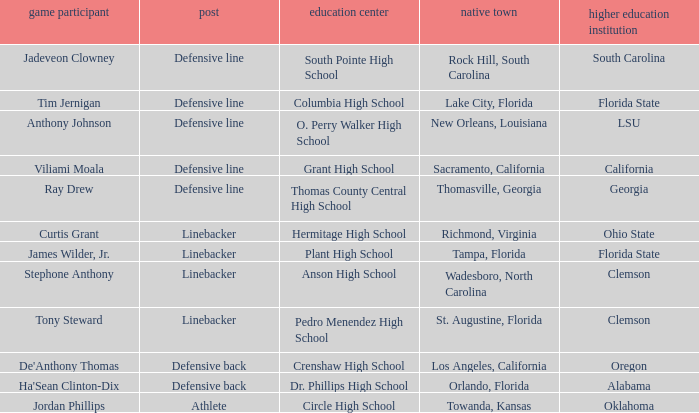What position is for Plant high school? Linebacker. 